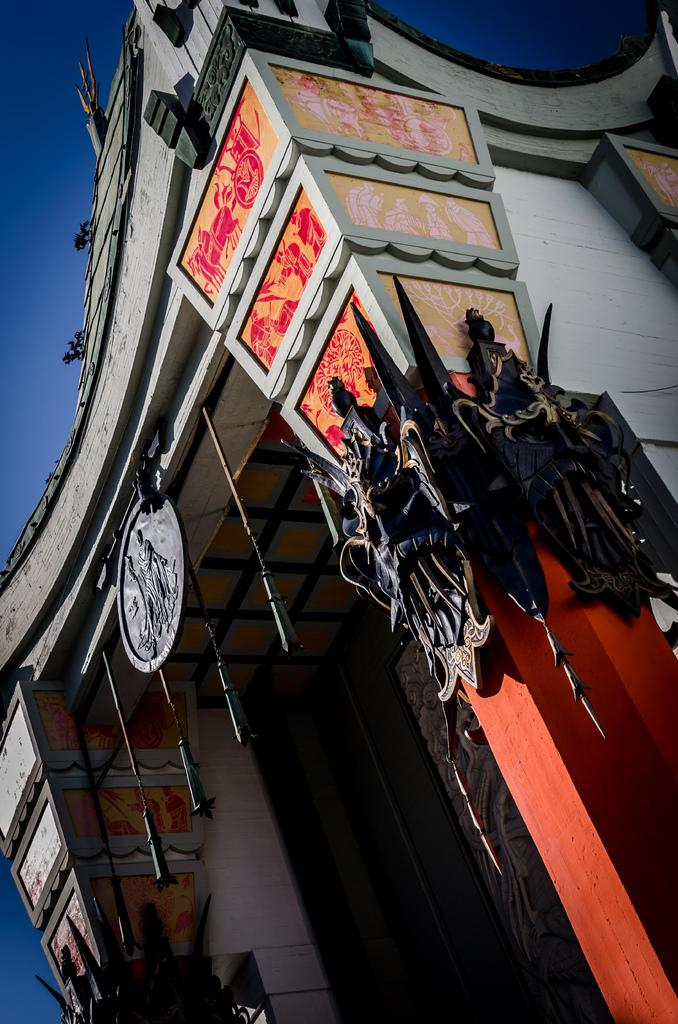What type of structure is present in the image? There is a building in the image. What other artistic elements can be seen in the image? There is a sculpture and posters in the image. What is visible in the background of the image? The sky is visible in the image. What is the color of the sky in the image? The color of the sky in the image is blue. How many potatoes are being used as a structure in the image? There are no potatoes present in the image, and they are not being used as a structure. 